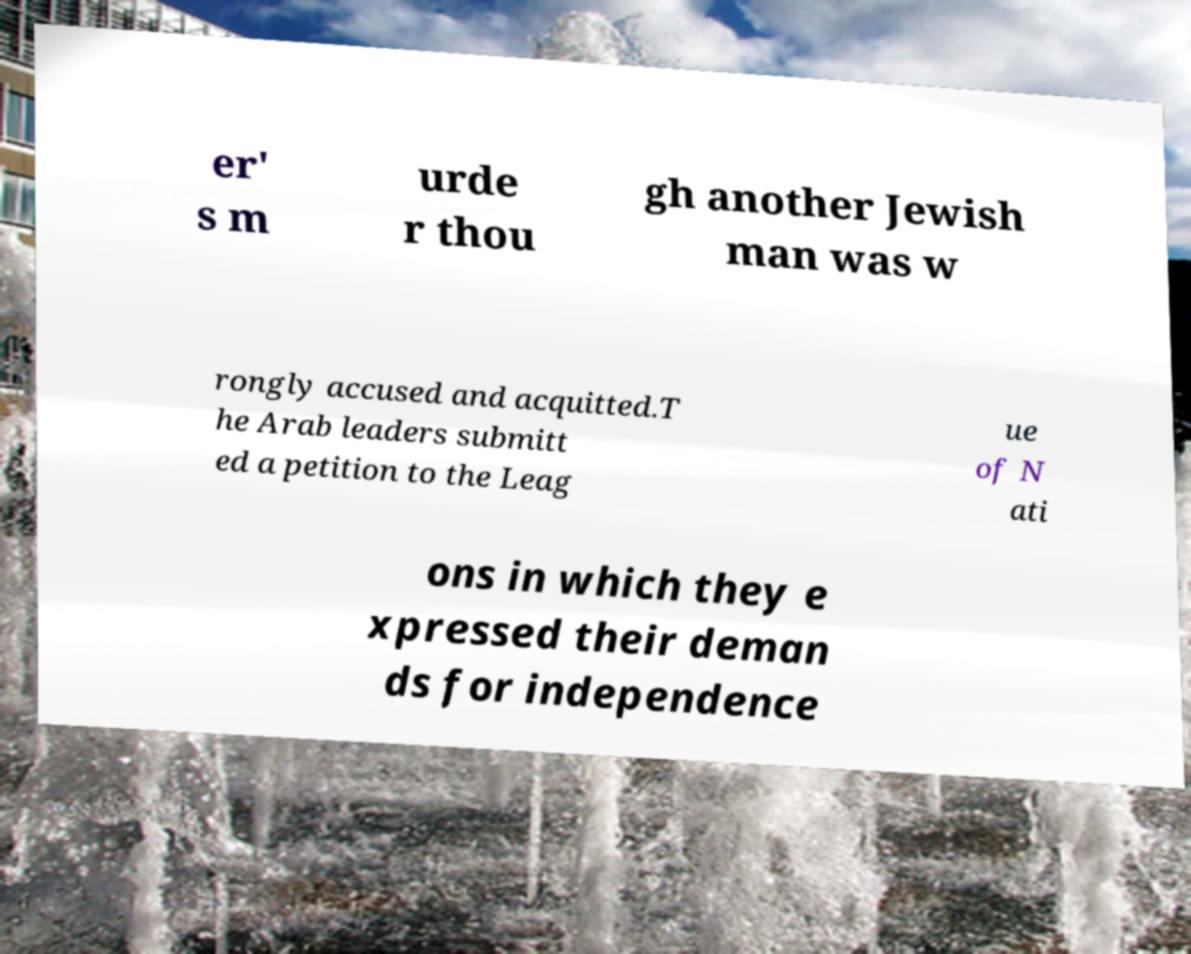There's text embedded in this image that I need extracted. Can you transcribe it verbatim? er' s m urde r thou gh another Jewish man was w rongly accused and acquitted.T he Arab leaders submitt ed a petition to the Leag ue of N ati ons in which they e xpressed their deman ds for independence 